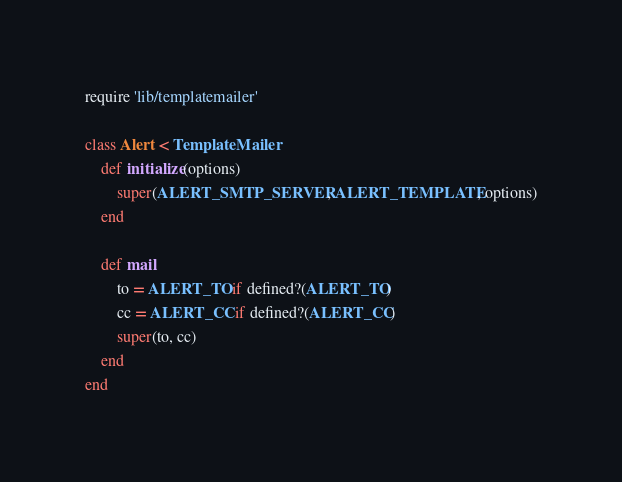<code> <loc_0><loc_0><loc_500><loc_500><_Ruby_>require 'lib/templatemailer'

class Alert < TemplateMailer
	def initialize(options)
		super(ALERT_SMTP_SERVER, ALERT_TEMPLATE, options)
	end

	def mail
		to = ALERT_TO if defined?(ALERT_TO)
		cc = ALERT_CC if defined?(ALERT_CC)
		super(to, cc)
	end
end
</code> 